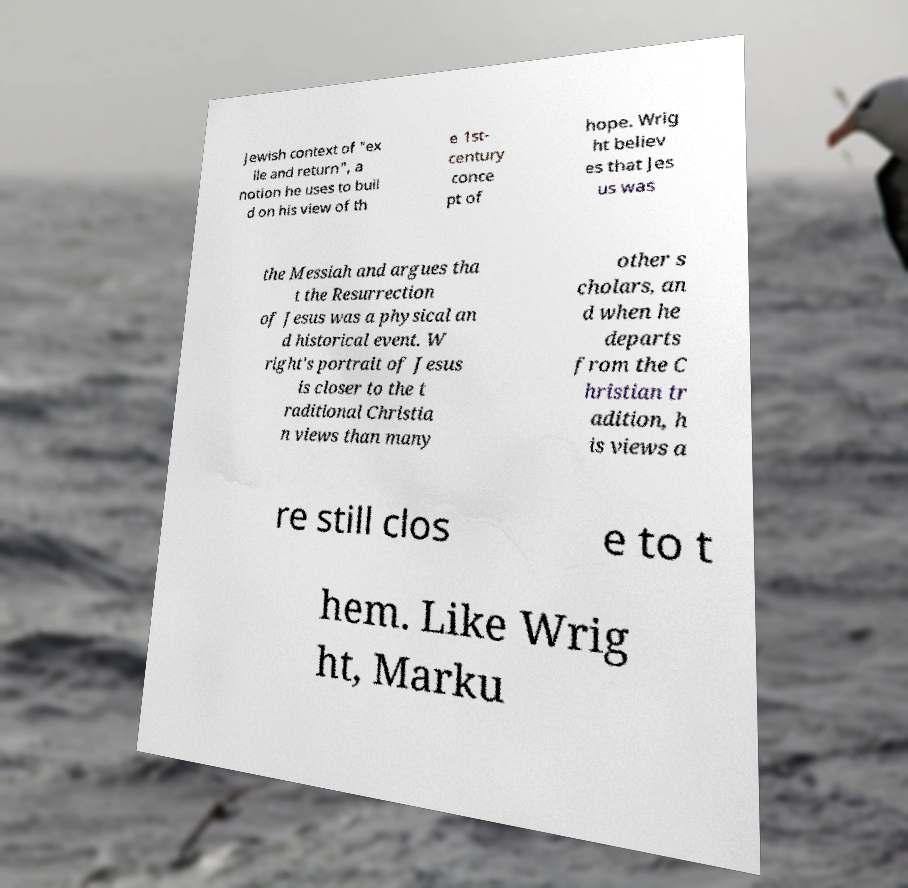There's text embedded in this image that I need extracted. Can you transcribe it verbatim? Jewish context of "ex ile and return", a notion he uses to buil d on his view of th e 1st- century conce pt of hope. Wrig ht believ es that Jes us was the Messiah and argues tha t the Resurrection of Jesus was a physical an d historical event. W right's portrait of Jesus is closer to the t raditional Christia n views than many other s cholars, an d when he departs from the C hristian tr adition, h is views a re still clos e to t hem. Like Wrig ht, Marku 